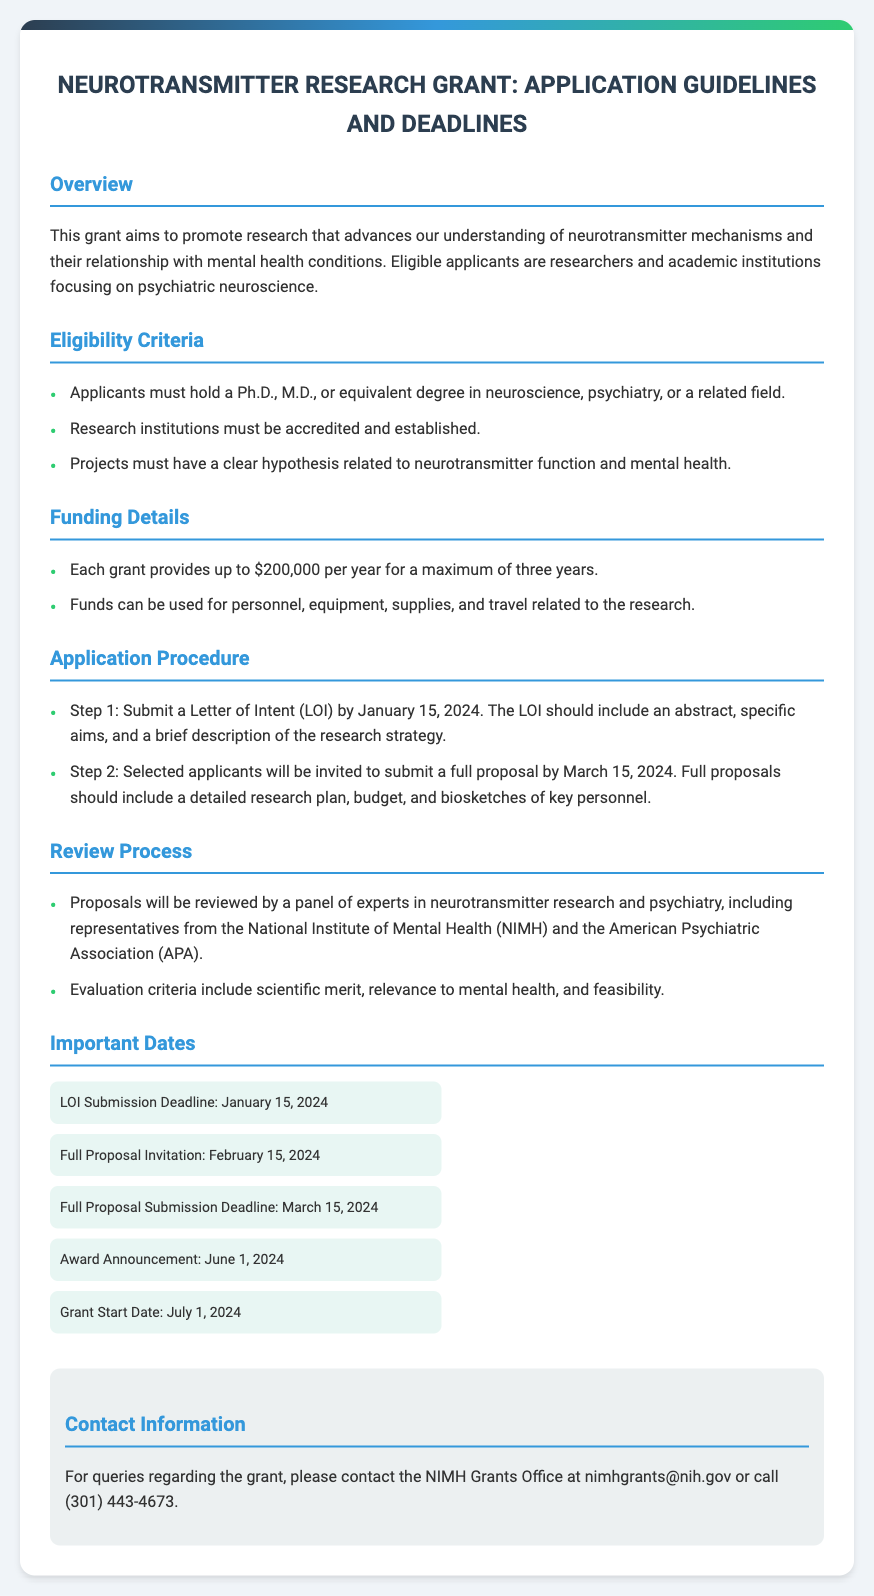What is the maximum funding per year? The maximum funding available for each grant is stated clearly in the funding details section of the document.
Answer: $200,000 When is the full proposal submission deadline? The document specifies important dates related to the submission process, including the deadline for full proposals.
Answer: March 15, 2024 Who can apply for the grant? The eligibility criteria detail the qualifications required for applicants to be eligible for the grant.
Answer: Researchers and academic institutions What is the duration of the grant? The funding details provide information about the maximum duration for which grants are awarded.
Answer: Three years What is required in the Letter of Intent (LOI)? The application procedure outlines the components that must be included in the LOI submitted by the applicants.
Answer: An abstract, specific aims, and a brief description of the research strategy When will the award announcement be made? The important dates section includes a specific date for the announcement of the grants.
Answer: June 1, 2024 What are the evaluation criteria for proposals? The review process section highlights the criteria by which the proposals will be evaluated.
Answer: Scientific merit, relevance to mental health, and feasibility What is the contact email for queries? The contact information section provides email details for inquiries about the grant.
Answer: nimhgrants@nih.gov 